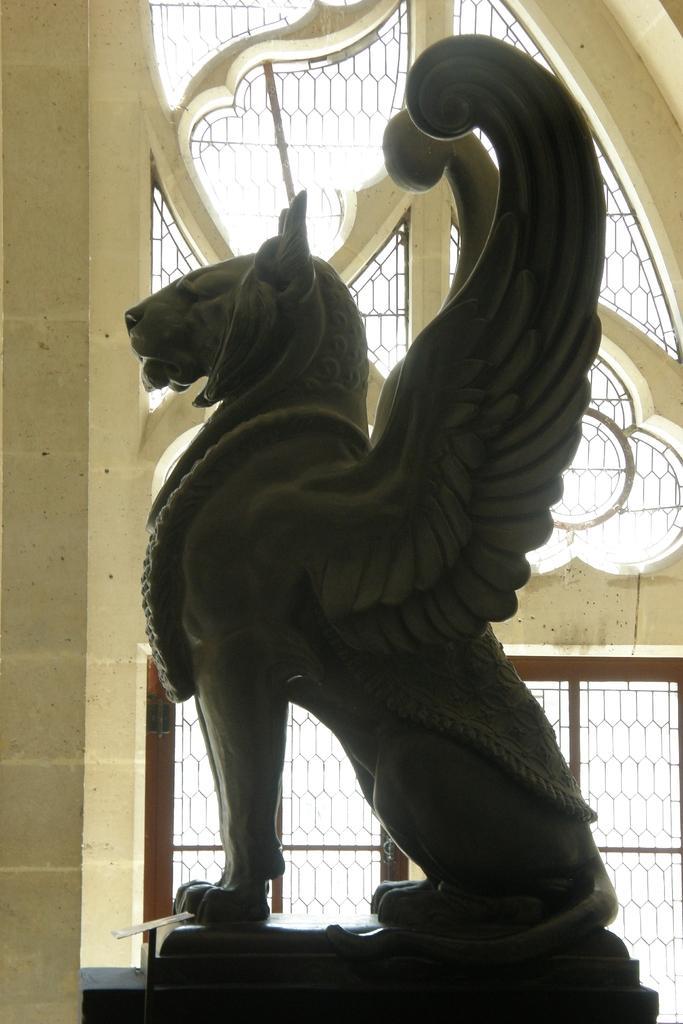Could you give a brief overview of what you see in this image? In the picture i can see a sculpture of an animal and in the background of the picture there is a wall and window. 